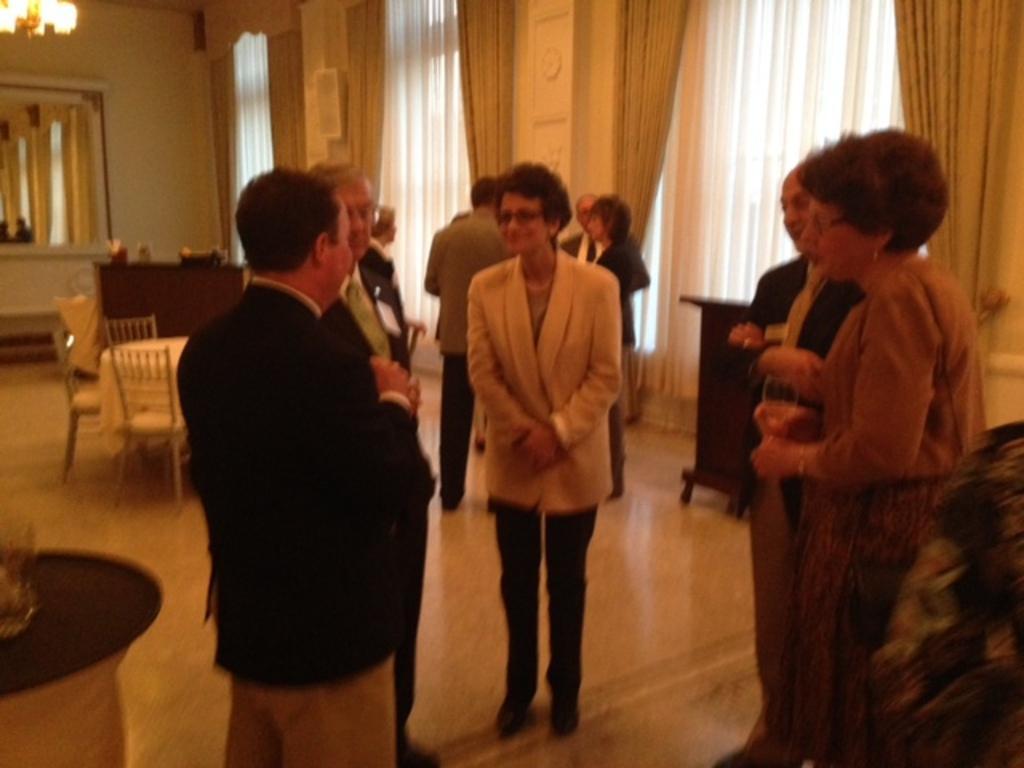Describe this image in one or two sentences. In this image, there are a few people. We can see the ground. We can see some chairs, tables with objects. We can also see a desk with some objects. We can see some curtains. We can also see the wall with some objects and a mirror. The reflection of people and the curtains is seen in the mirror. We can also see the light on the top left corner. We can see some wood. 